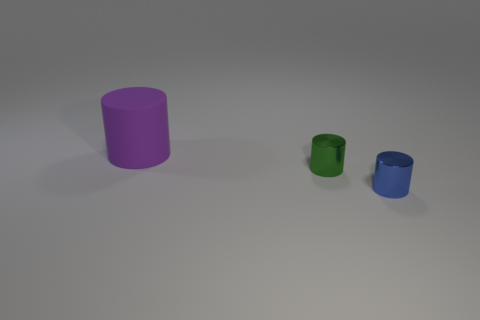Add 2 red metal blocks. How many objects exist? 5 Subtract all small green shiny cylinders. Subtract all small green things. How many objects are left? 1 Add 3 tiny blue cylinders. How many tiny blue cylinders are left? 4 Add 2 tiny cylinders. How many tiny cylinders exist? 4 Subtract 0 green balls. How many objects are left? 3 